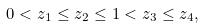Convert formula to latex. <formula><loc_0><loc_0><loc_500><loc_500>0 < z _ { 1 } \leq z _ { 2 } \leq 1 < z _ { 3 } \leq z _ { 4 } ,</formula> 